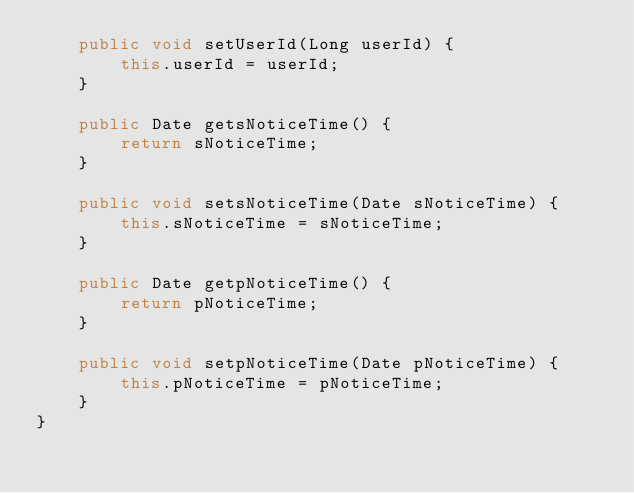Convert code to text. <code><loc_0><loc_0><loc_500><loc_500><_Java_>    public void setUserId(Long userId) {
        this.userId = userId;
    }

    public Date getsNoticeTime() {
        return sNoticeTime;
    }

    public void setsNoticeTime(Date sNoticeTime) {
        this.sNoticeTime = sNoticeTime;
    }

    public Date getpNoticeTime() {
        return pNoticeTime;
    }

    public void setpNoticeTime(Date pNoticeTime) {
        this.pNoticeTime = pNoticeTime;
    }
}</code> 